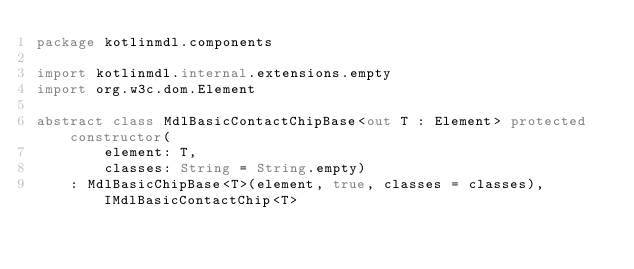Convert code to text. <code><loc_0><loc_0><loc_500><loc_500><_Kotlin_>package kotlinmdl.components

import kotlinmdl.internal.extensions.empty
import org.w3c.dom.Element

abstract class MdlBasicContactChipBase<out T : Element> protected constructor(
        element: T,
        classes: String = String.empty)
    : MdlBasicChipBase<T>(element, true, classes = classes), IMdlBasicContactChip<T>
</code> 